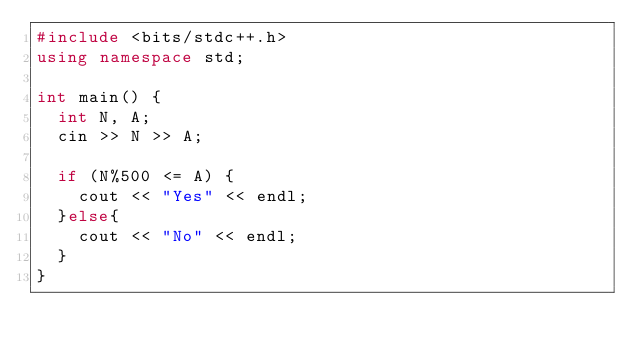Convert code to text. <code><loc_0><loc_0><loc_500><loc_500><_C++_>#include <bits/stdc++.h>
using namespace std;

int main() {
  int N, A;
  cin >> N >> A;

  if (N%500 <= A) {
    cout << "Yes" << endl;
  }else{
    cout << "No" << endl;
  } 
}</code> 